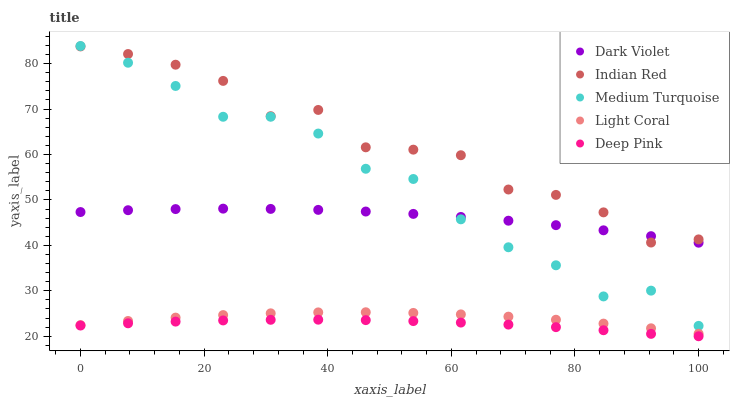Does Deep Pink have the minimum area under the curve?
Answer yes or no. Yes. Does Indian Red have the maximum area under the curve?
Answer yes or no. Yes. Does Medium Turquoise have the minimum area under the curve?
Answer yes or no. No. Does Medium Turquoise have the maximum area under the curve?
Answer yes or no. No. Is Deep Pink the smoothest?
Answer yes or no. Yes. Is Indian Red the roughest?
Answer yes or no. Yes. Is Medium Turquoise the smoothest?
Answer yes or no. No. Is Medium Turquoise the roughest?
Answer yes or no. No. Does Deep Pink have the lowest value?
Answer yes or no. Yes. Does Medium Turquoise have the lowest value?
Answer yes or no. No. Does Medium Turquoise have the highest value?
Answer yes or no. Yes. Does Deep Pink have the highest value?
Answer yes or no. No. Is Light Coral less than Medium Turquoise?
Answer yes or no. Yes. Is Medium Turquoise greater than Light Coral?
Answer yes or no. Yes. Does Indian Red intersect Medium Turquoise?
Answer yes or no. Yes. Is Indian Red less than Medium Turquoise?
Answer yes or no. No. Is Indian Red greater than Medium Turquoise?
Answer yes or no. No. Does Light Coral intersect Medium Turquoise?
Answer yes or no. No. 